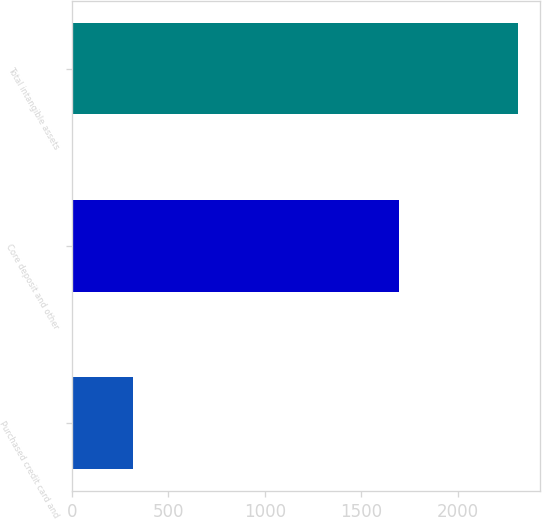Convert chart to OTSL. <chart><loc_0><loc_0><loc_500><loc_500><bar_chart><fcel>Purchased credit card and<fcel>Core deposit and other<fcel>Total intangible assets<nl><fcel>315<fcel>1695<fcel>2312<nl></chart> 